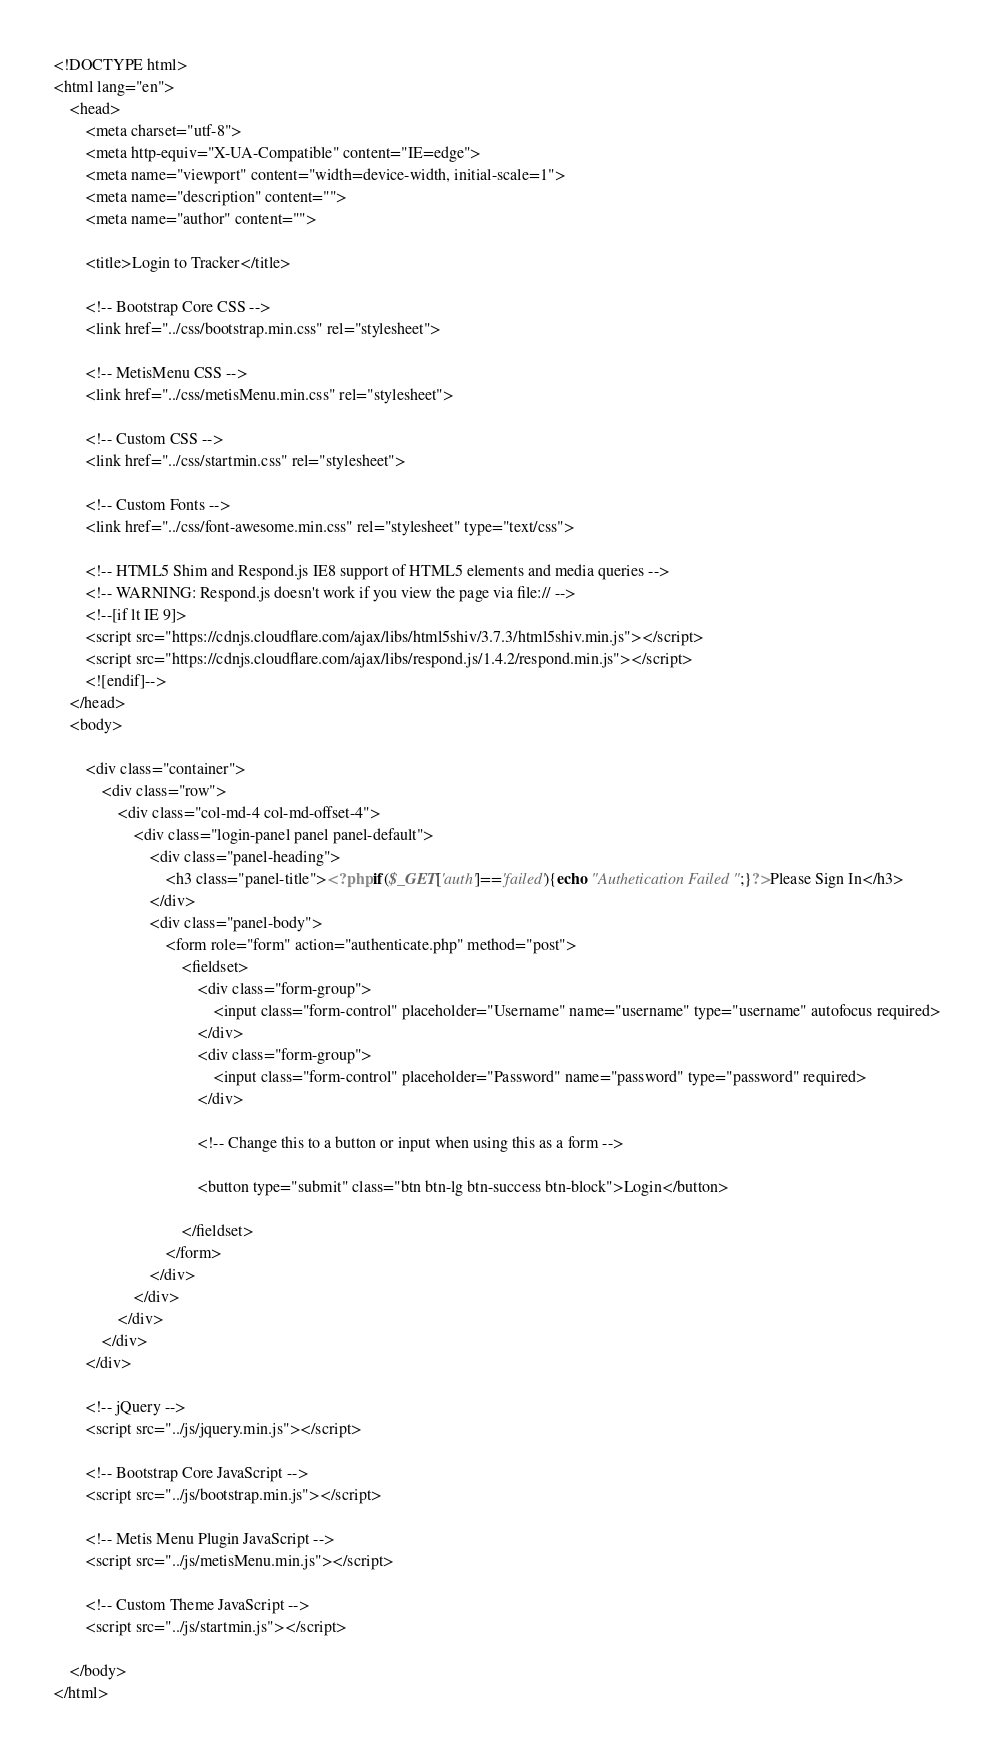<code> <loc_0><loc_0><loc_500><loc_500><_PHP_><!DOCTYPE html>
<html lang="en">
    <head>
        <meta charset="utf-8">
        <meta http-equiv="X-UA-Compatible" content="IE=edge">
        <meta name="viewport" content="width=device-width, initial-scale=1">
        <meta name="description" content="">
        <meta name="author" content="">

        <title>Login to Tracker</title>

        <!-- Bootstrap Core CSS -->
        <link href="../css/bootstrap.min.css" rel="stylesheet">

        <!-- MetisMenu CSS -->
        <link href="../css/metisMenu.min.css" rel="stylesheet">

        <!-- Custom CSS -->
        <link href="../css/startmin.css" rel="stylesheet">

        <!-- Custom Fonts -->
        <link href="../css/font-awesome.min.css" rel="stylesheet" type="text/css">

        <!-- HTML5 Shim and Respond.js IE8 support of HTML5 elements and media queries -->
        <!-- WARNING: Respond.js doesn't work if you view the page via file:// -->
        <!--[if lt IE 9]>
        <script src="https://cdnjs.cloudflare.com/ajax/libs/html5shiv/3.7.3/html5shiv.min.js"></script>
        <script src="https://cdnjs.cloudflare.com/ajax/libs/respond.js/1.4.2/respond.min.js"></script>
        <![endif]-->
    </head>
    <body>

        <div class="container">
            <div class="row">
                <div class="col-md-4 col-md-offset-4">
                    <div class="login-panel panel panel-default">
                        <div class="panel-heading">
                            <h3 class="panel-title"><?php if($_GET['auth']=='failed'){echo "Authetication Failed ";}?>Please Sign In</h3>
                        </div>
                        <div class="panel-body">
                            <form role="form" action="authenticate.php" method="post">
                                <fieldset>
                                    <div class="form-group">
                                        <input class="form-control" placeholder="Username" name="username" type="username" autofocus required>
                                    </div>
                                    <div class="form-group">
                                        <input class="form-control" placeholder="Password" name="password" type="password" required>
                                    </div>
                                    
                                    <!-- Change this to a button or input when using this as a form -->
                                    
                                    <button type="submit" class="btn btn-lg btn-success btn-block">Login</button>
                                    
                                </fieldset>
                            </form>
                        </div>
                    </div>
                </div>
            </div>
        </div>

        <!-- jQuery -->
        <script src="../js/jquery.min.js"></script>

        <!-- Bootstrap Core JavaScript -->
        <script src="../js/bootstrap.min.js"></script>

        <!-- Metis Menu Plugin JavaScript -->
        <script src="../js/metisMenu.min.js"></script>

        <!-- Custom Theme JavaScript -->
        <script src="../js/startmin.js"></script>

    </body>
</html>
</code> 